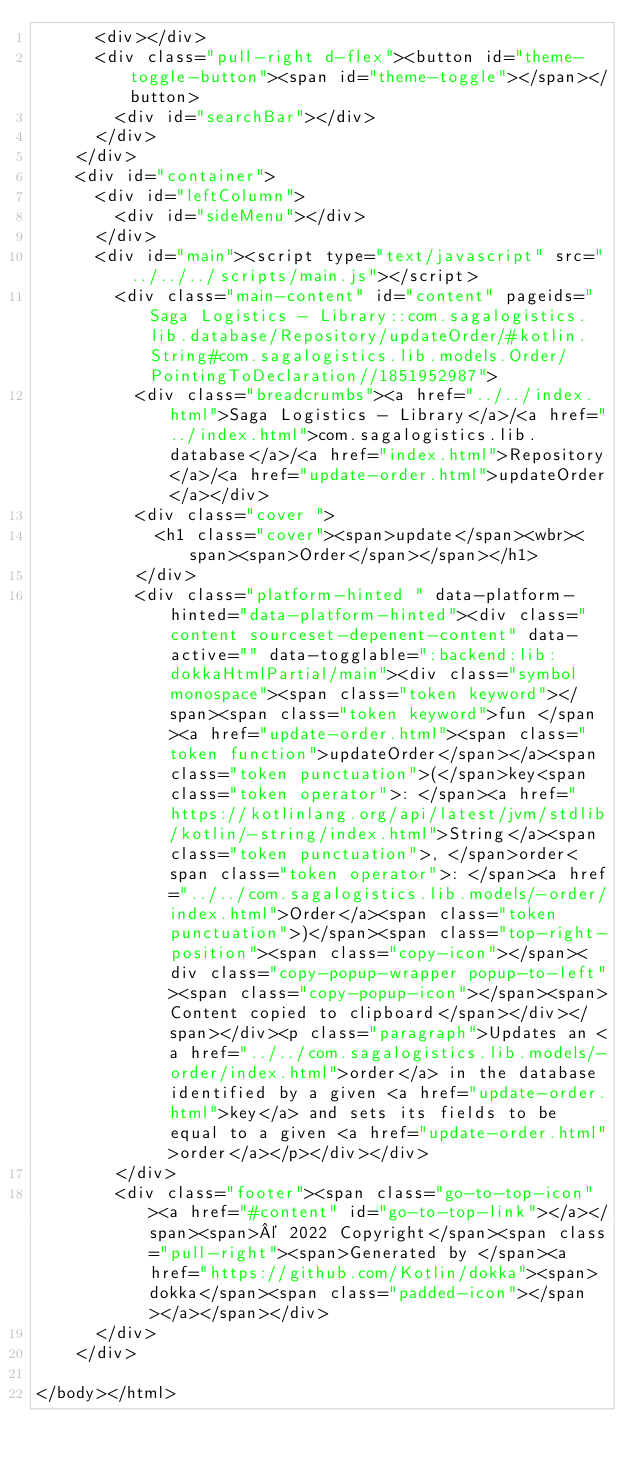<code> <loc_0><loc_0><loc_500><loc_500><_HTML_>      <div></div>
      <div class="pull-right d-flex"><button id="theme-toggle-button"><span id="theme-toggle"></span></button>
        <div id="searchBar"></div>
      </div>
    </div>
    <div id="container">
      <div id="leftColumn">
        <div id="sideMenu"></div>
      </div>
      <div id="main"><script type="text/javascript" src="../../../scripts/main.js"></script>
        <div class="main-content" id="content" pageids="Saga Logistics - Library::com.sagalogistics.lib.database/Repository/updateOrder/#kotlin.String#com.sagalogistics.lib.models.Order/PointingToDeclaration//1851952987">
          <div class="breadcrumbs"><a href="../../index.html">Saga Logistics - Library</a>/<a href="../index.html">com.sagalogistics.lib.database</a>/<a href="index.html">Repository</a>/<a href="update-order.html">updateOrder</a></div>
          <div class="cover ">
            <h1 class="cover"><span>update</span><wbr><span><span>Order</span></span></h1>
          </div>
          <div class="platform-hinted " data-platform-hinted="data-platform-hinted"><div class="content sourceset-depenent-content" data-active="" data-togglable=":backend:lib:dokkaHtmlPartial/main"><div class="symbol monospace"><span class="token keyword"></span><span class="token keyword">fun </span><a href="update-order.html"><span class="token function">updateOrder</span></a><span class="token punctuation">(</span>key<span class="token operator">: </span><a href="https://kotlinlang.org/api/latest/jvm/stdlib/kotlin/-string/index.html">String</a><span class="token punctuation">, </span>order<span class="token operator">: </span><a href="../../com.sagalogistics.lib.models/-order/index.html">Order</a><span class="token punctuation">)</span><span class="top-right-position"><span class="copy-icon"></span><div class="copy-popup-wrapper popup-to-left"><span class="copy-popup-icon"></span><span>Content copied to clipboard</span></div></span></div><p class="paragraph">Updates an <a href="../../com.sagalogistics.lib.models/-order/index.html">order</a> in the database identified by a given <a href="update-order.html">key</a> and sets its fields to be equal to a given <a href="update-order.html">order</a></p></div></div>
        </div>
        <div class="footer"><span class="go-to-top-icon"><a href="#content" id="go-to-top-link"></a></span><span>© 2022 Copyright</span><span class="pull-right"><span>Generated by </span><a href="https://github.com/Kotlin/dokka"><span>dokka</span><span class="padded-icon"></span></a></span></div>
      </div>
    </div>
  
</body></html>


</code> 